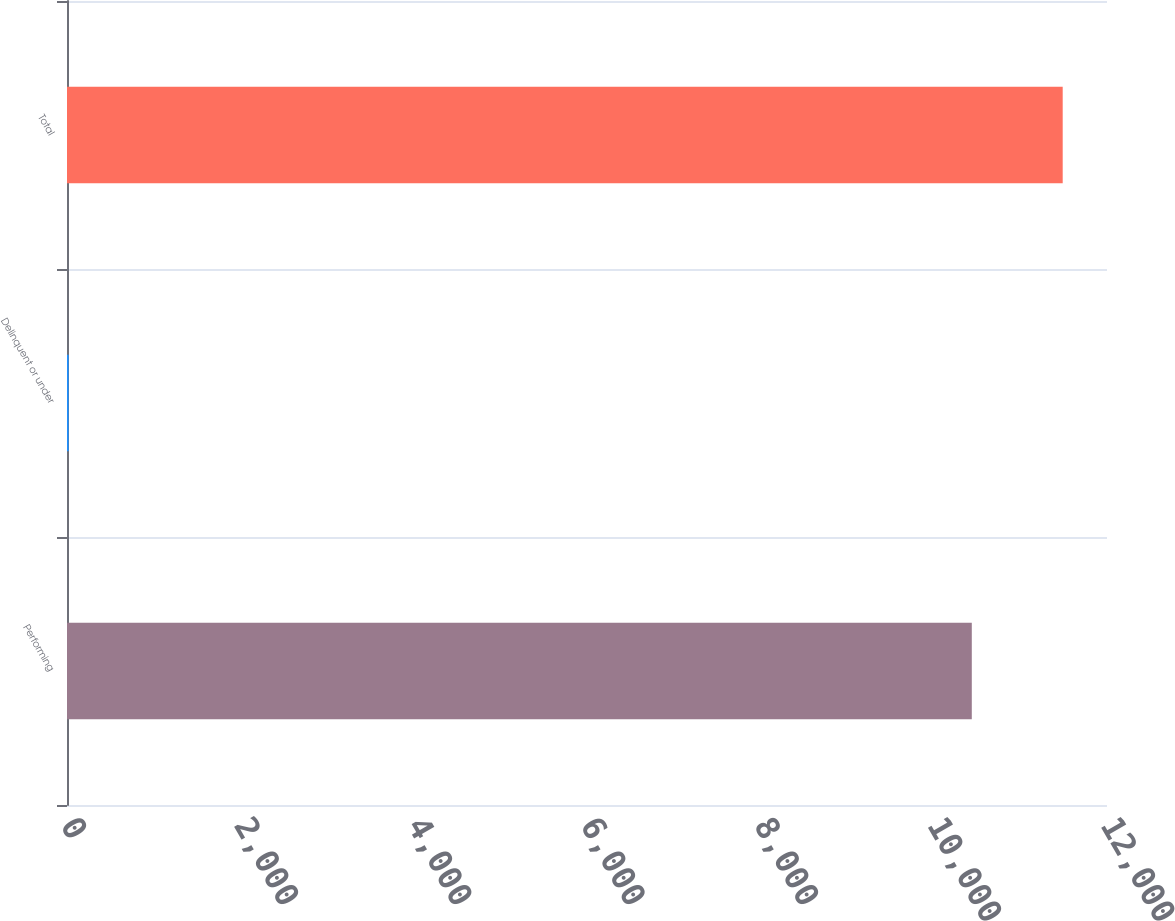Convert chart. <chart><loc_0><loc_0><loc_500><loc_500><bar_chart><fcel>Performing<fcel>Delinquent or under<fcel>Total<nl><fcel>10440<fcel>19<fcel>11488.9<nl></chart> 